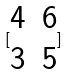Convert formula to latex. <formula><loc_0><loc_0><loc_500><loc_500>[ \begin{matrix} 4 & 6 \\ 3 & 5 \end{matrix} ]</formula> 